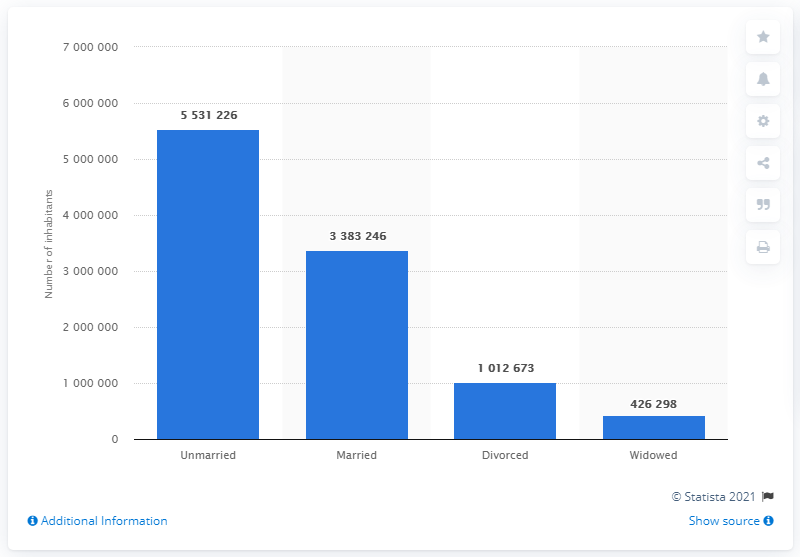Point out several critical features in this image. In 2020, there were approximately 5,531,226 unmarried Swedish people. In 2020, a total of 426,298 Swedish residents experienced the loss of their spouse, resulting in a significant increase from the previous year. In 2020, a total of 338,324 people in Sweden were married. In 2020, a total of 426,298 Swedish residents experienced a divorce. 